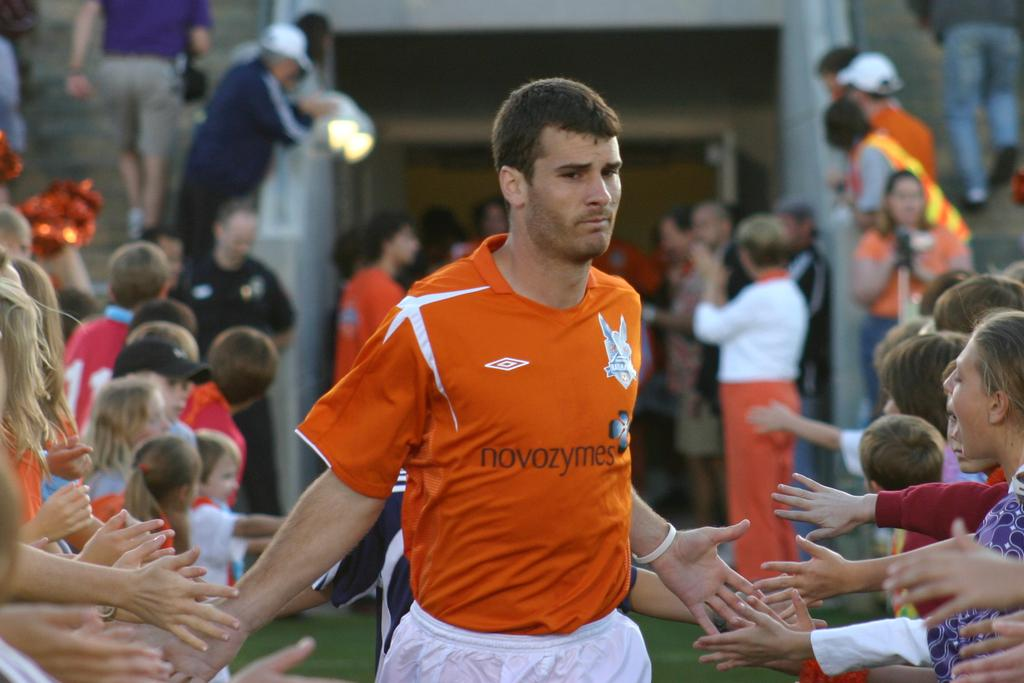<image>
Give a short and clear explanation of the subsequent image. The soccer player is wearing an orange jersey sponsored by Novozymes. 